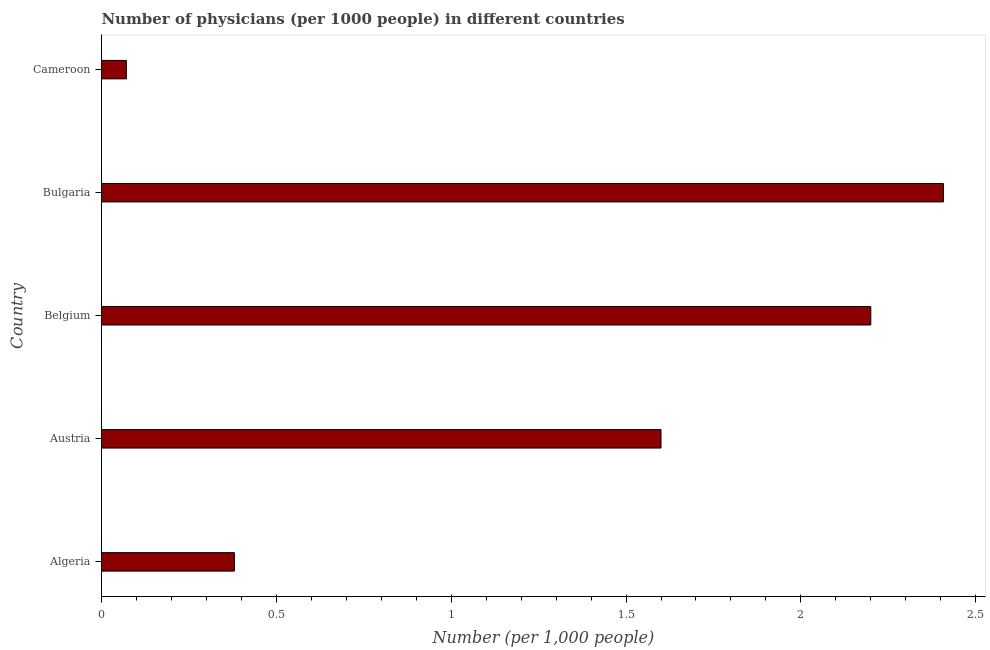Does the graph contain grids?
Your response must be concise. No. What is the title of the graph?
Keep it short and to the point. Number of physicians (per 1000 people) in different countries. What is the label or title of the X-axis?
Provide a succinct answer. Number (per 1,0 people). What is the number of physicians in Austria?
Provide a short and direct response. 1.6. Across all countries, what is the maximum number of physicians?
Keep it short and to the point. 2.41. Across all countries, what is the minimum number of physicians?
Ensure brevity in your answer.  0.07. In which country was the number of physicians maximum?
Offer a terse response. Bulgaria. In which country was the number of physicians minimum?
Make the answer very short. Cameroon. What is the sum of the number of physicians?
Keep it short and to the point. 6.66. What is the difference between the number of physicians in Algeria and Belgium?
Provide a succinct answer. -1.82. What is the average number of physicians per country?
Your answer should be very brief. 1.33. What is the ratio of the number of physicians in Algeria to that in Bulgaria?
Your answer should be very brief. 0.16. What is the difference between the highest and the second highest number of physicians?
Give a very brief answer. 0.21. Is the sum of the number of physicians in Algeria and Austria greater than the maximum number of physicians across all countries?
Offer a terse response. No. What is the difference between the highest and the lowest number of physicians?
Keep it short and to the point. 2.34. In how many countries, is the number of physicians greater than the average number of physicians taken over all countries?
Your answer should be compact. 3. Are all the bars in the graph horizontal?
Your answer should be very brief. Yes. How many countries are there in the graph?
Ensure brevity in your answer.  5. What is the difference between two consecutive major ticks on the X-axis?
Ensure brevity in your answer.  0.5. What is the Number (per 1,000 people) in Algeria?
Offer a very short reply. 0.38. What is the Number (per 1,000 people) in Austria?
Your answer should be compact. 1.6. What is the Number (per 1,000 people) in Bulgaria?
Give a very brief answer. 2.41. What is the Number (per 1,000 people) of Cameroon?
Make the answer very short. 0.07. What is the difference between the Number (per 1,000 people) in Algeria and Austria?
Provide a short and direct response. -1.22. What is the difference between the Number (per 1,000 people) in Algeria and Belgium?
Ensure brevity in your answer.  -1.82. What is the difference between the Number (per 1,000 people) in Algeria and Bulgaria?
Offer a very short reply. -2.03. What is the difference between the Number (per 1,000 people) in Algeria and Cameroon?
Provide a short and direct response. 0.31. What is the difference between the Number (per 1,000 people) in Austria and Belgium?
Your response must be concise. -0.6. What is the difference between the Number (per 1,000 people) in Austria and Bulgaria?
Provide a short and direct response. -0.81. What is the difference between the Number (per 1,000 people) in Austria and Cameroon?
Your answer should be very brief. 1.53. What is the difference between the Number (per 1,000 people) in Belgium and Bulgaria?
Your answer should be compact. -0.21. What is the difference between the Number (per 1,000 people) in Belgium and Cameroon?
Make the answer very short. 2.13. What is the difference between the Number (per 1,000 people) in Bulgaria and Cameroon?
Offer a very short reply. 2.34. What is the ratio of the Number (per 1,000 people) in Algeria to that in Austria?
Keep it short and to the point. 0.24. What is the ratio of the Number (per 1,000 people) in Algeria to that in Belgium?
Provide a short and direct response. 0.17. What is the ratio of the Number (per 1,000 people) in Algeria to that in Bulgaria?
Offer a very short reply. 0.16. What is the ratio of the Number (per 1,000 people) in Algeria to that in Cameroon?
Give a very brief answer. 5.35. What is the ratio of the Number (per 1,000 people) in Austria to that in Belgium?
Provide a succinct answer. 0.73. What is the ratio of the Number (per 1,000 people) in Austria to that in Bulgaria?
Offer a very short reply. 0.67. What is the ratio of the Number (per 1,000 people) in Austria to that in Cameroon?
Offer a very short reply. 22.5. What is the ratio of the Number (per 1,000 people) in Belgium to that in Bulgaria?
Provide a succinct answer. 0.91. What is the ratio of the Number (per 1,000 people) in Belgium to that in Cameroon?
Your response must be concise. 30.94. What is the ratio of the Number (per 1,000 people) in Bulgaria to that in Cameroon?
Keep it short and to the point. 33.86. 